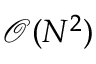Convert formula to latex. <formula><loc_0><loc_0><loc_500><loc_500>\mathcal { O } ( N ^ { 2 } )</formula> 